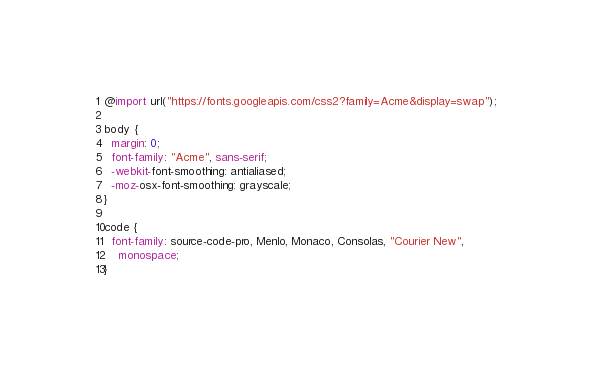<code> <loc_0><loc_0><loc_500><loc_500><_CSS_>@import url("https://fonts.googleapis.com/css2?family=Acme&display=swap");

body {
  margin: 0;
  font-family: "Acme", sans-serif;
  -webkit-font-smoothing: antialiased;
  -moz-osx-font-smoothing: grayscale;
}

code {
  font-family: source-code-pro, Menlo, Monaco, Consolas, "Courier New",
    monospace;
}
</code> 